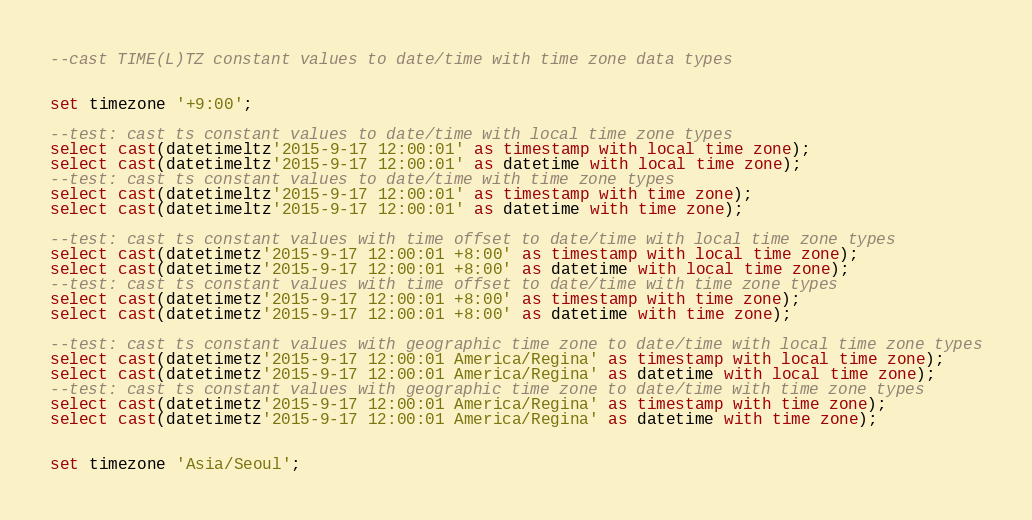<code> <loc_0><loc_0><loc_500><loc_500><_SQL_>--cast TIME(L)TZ constant values to date/time with time zone data types


set timezone '+9:00';

--test: cast ts constant values to date/time with local time zone types
select cast(datetimeltz'2015-9-17 12:00:01' as timestamp with local time zone);
select cast(datetimeltz'2015-9-17 12:00:01' as datetime with local time zone);
--test: cast ts constant values to date/time with time zone types
select cast(datetimeltz'2015-9-17 12:00:01' as timestamp with time zone);
select cast(datetimeltz'2015-9-17 12:00:01' as datetime with time zone);

--test: cast ts constant values with time offset to date/time with local time zone types
select cast(datetimetz'2015-9-17 12:00:01 +8:00' as timestamp with local time zone);
select cast(datetimetz'2015-9-17 12:00:01 +8:00' as datetime with local time zone);
--test: cast ts constant values with time offset to date/time with time zone types
select cast(datetimetz'2015-9-17 12:00:01 +8:00' as timestamp with time zone);
select cast(datetimetz'2015-9-17 12:00:01 +8:00' as datetime with time zone);

--test: cast ts constant values with geographic time zone to date/time with local time zone types
select cast(datetimetz'2015-9-17 12:00:01 America/Regina' as timestamp with local time zone);
select cast(datetimetz'2015-9-17 12:00:01 America/Regina' as datetime with local time zone);
--test: cast ts constant values with geographic time zone to date/time with time zone types
select cast(datetimetz'2015-9-17 12:00:01 America/Regina' as timestamp with time zone);
select cast(datetimetz'2015-9-17 12:00:01 America/Regina' as datetime with time zone);


set timezone 'Asia/Seoul';
</code> 